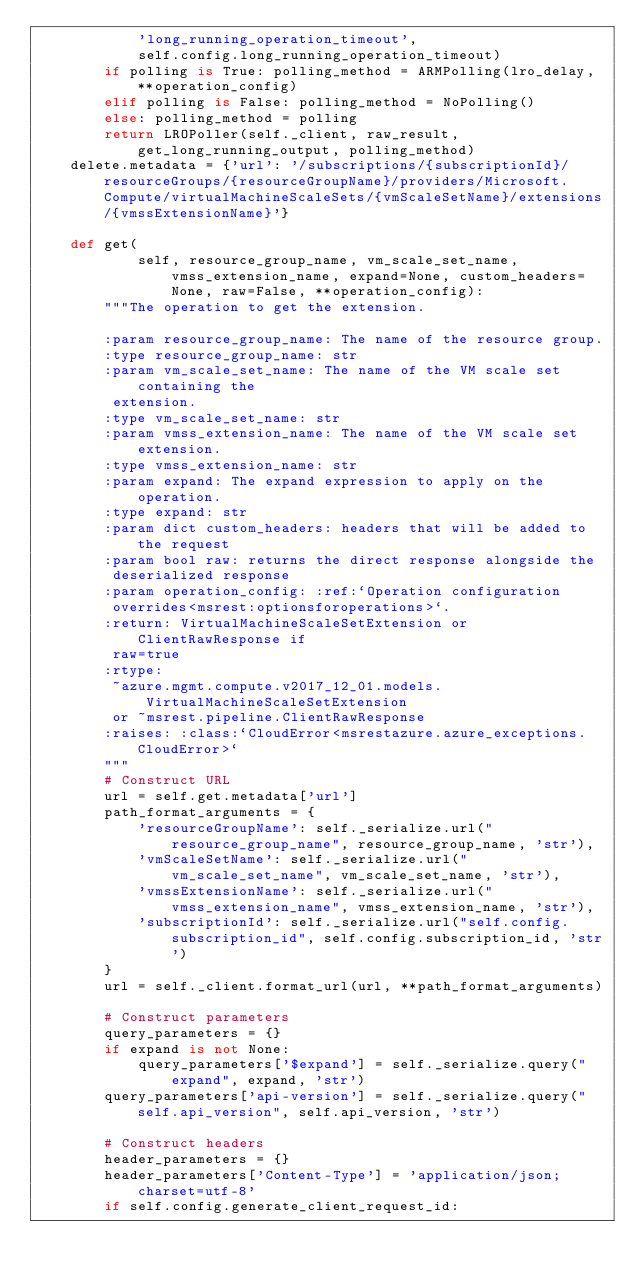<code> <loc_0><loc_0><loc_500><loc_500><_Python_>            'long_running_operation_timeout',
            self.config.long_running_operation_timeout)
        if polling is True: polling_method = ARMPolling(lro_delay, **operation_config)
        elif polling is False: polling_method = NoPolling()
        else: polling_method = polling
        return LROPoller(self._client, raw_result, get_long_running_output, polling_method)
    delete.metadata = {'url': '/subscriptions/{subscriptionId}/resourceGroups/{resourceGroupName}/providers/Microsoft.Compute/virtualMachineScaleSets/{vmScaleSetName}/extensions/{vmssExtensionName}'}

    def get(
            self, resource_group_name, vm_scale_set_name, vmss_extension_name, expand=None, custom_headers=None, raw=False, **operation_config):
        """The operation to get the extension.

        :param resource_group_name: The name of the resource group.
        :type resource_group_name: str
        :param vm_scale_set_name: The name of the VM scale set containing the
         extension.
        :type vm_scale_set_name: str
        :param vmss_extension_name: The name of the VM scale set extension.
        :type vmss_extension_name: str
        :param expand: The expand expression to apply on the operation.
        :type expand: str
        :param dict custom_headers: headers that will be added to the request
        :param bool raw: returns the direct response alongside the
         deserialized response
        :param operation_config: :ref:`Operation configuration
         overrides<msrest:optionsforoperations>`.
        :return: VirtualMachineScaleSetExtension or ClientRawResponse if
         raw=true
        :rtype:
         ~azure.mgmt.compute.v2017_12_01.models.VirtualMachineScaleSetExtension
         or ~msrest.pipeline.ClientRawResponse
        :raises: :class:`CloudError<msrestazure.azure_exceptions.CloudError>`
        """
        # Construct URL
        url = self.get.metadata['url']
        path_format_arguments = {
            'resourceGroupName': self._serialize.url("resource_group_name", resource_group_name, 'str'),
            'vmScaleSetName': self._serialize.url("vm_scale_set_name", vm_scale_set_name, 'str'),
            'vmssExtensionName': self._serialize.url("vmss_extension_name", vmss_extension_name, 'str'),
            'subscriptionId': self._serialize.url("self.config.subscription_id", self.config.subscription_id, 'str')
        }
        url = self._client.format_url(url, **path_format_arguments)

        # Construct parameters
        query_parameters = {}
        if expand is not None:
            query_parameters['$expand'] = self._serialize.query("expand", expand, 'str')
        query_parameters['api-version'] = self._serialize.query("self.api_version", self.api_version, 'str')

        # Construct headers
        header_parameters = {}
        header_parameters['Content-Type'] = 'application/json; charset=utf-8'
        if self.config.generate_client_request_id:</code> 